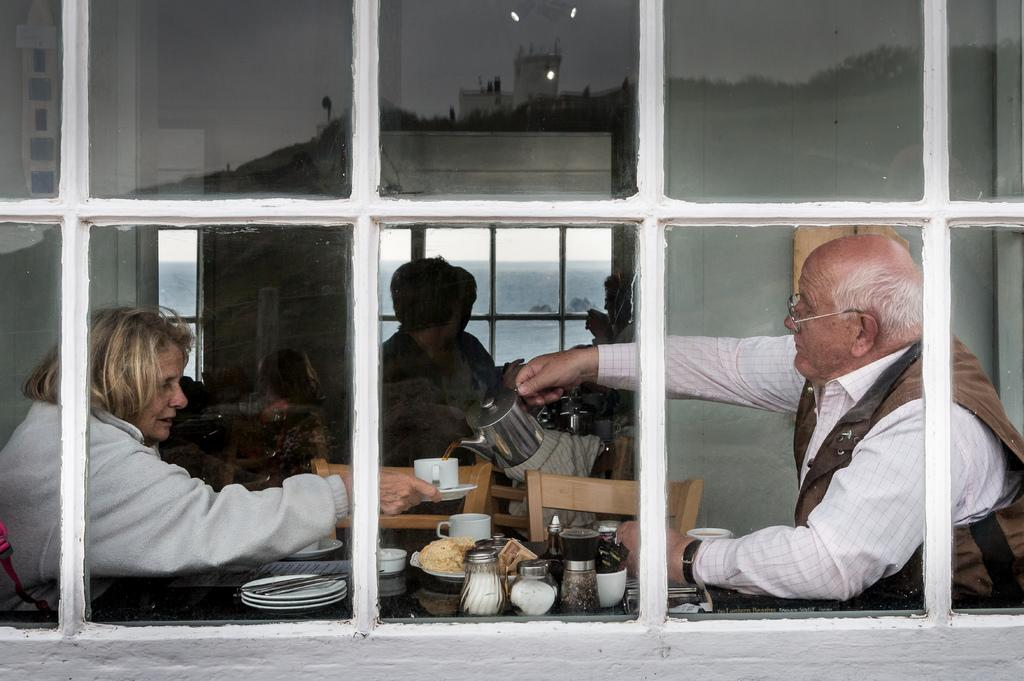What are the people in the image doing? There is a group of persons sitting in the image. What is in front of the group? There is a table in front of the group. What can be seen on the table? There are plates and cups on the table. Are there any other objects on the table? Yes, there are other objects on the table. What is visible through the window in the image? The sky is visible in the image. What type of soup is being served in the pizzas on the table? There are no pizzas present in the image, and soup is not mentioned as one of the items on the table. 